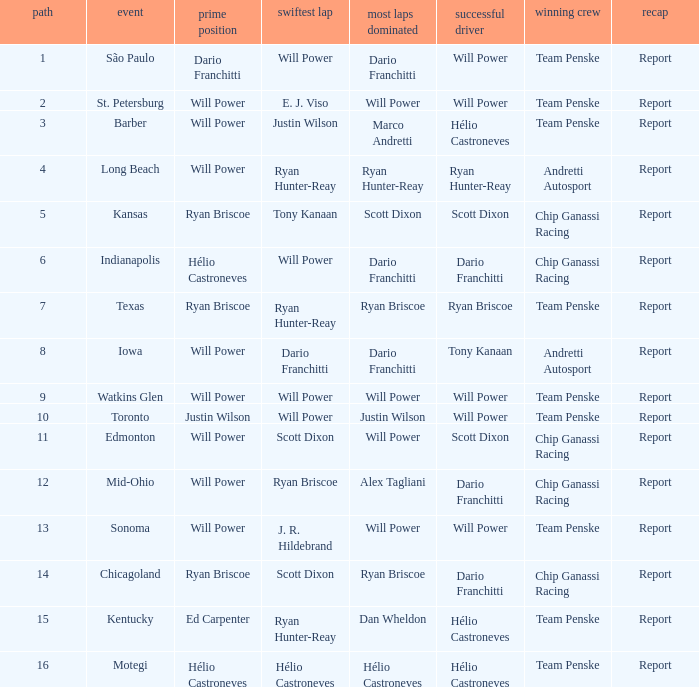What is the report for races where Will Power had both pole position and fastest lap? Report. 